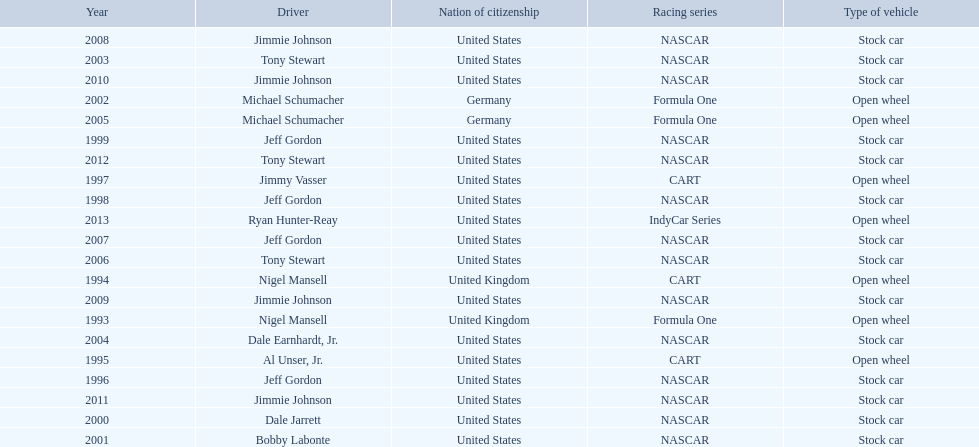Which drivers have won the best driver espy award? Nigel Mansell, Nigel Mansell, Al Unser, Jr., Jeff Gordon, Jimmy Vasser, Jeff Gordon, Jeff Gordon, Dale Jarrett, Bobby Labonte, Michael Schumacher, Tony Stewart, Dale Earnhardt, Jr., Michael Schumacher, Tony Stewart, Jeff Gordon, Jimmie Johnson, Jimmie Johnson, Jimmie Johnson, Jimmie Johnson, Tony Stewart, Ryan Hunter-Reay. Of these, which only appear once? Al Unser, Jr., Jimmy Vasser, Dale Jarrett, Dale Earnhardt, Jr., Ryan Hunter-Reay. Which of these are from the cart racing series? Al Unser, Jr., Jimmy Vasser. Of these, which received their award first? Al Unser, Jr. 